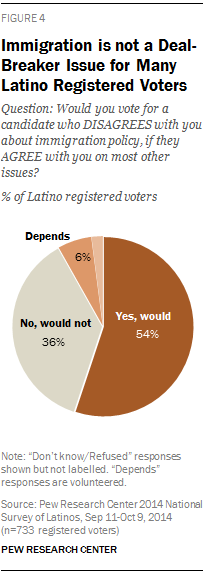Mention a couple of crucial points in this snapshot. The PIE graph does not show the full value of 0.04. The phrase "What does Grey represent in the Pie graph? No, would not" is a question asking about the meaning or significance of the color grey in a pie graph. The speaker is indicating that grey is not a valid piece of information in the pie graph and should not be considered. 